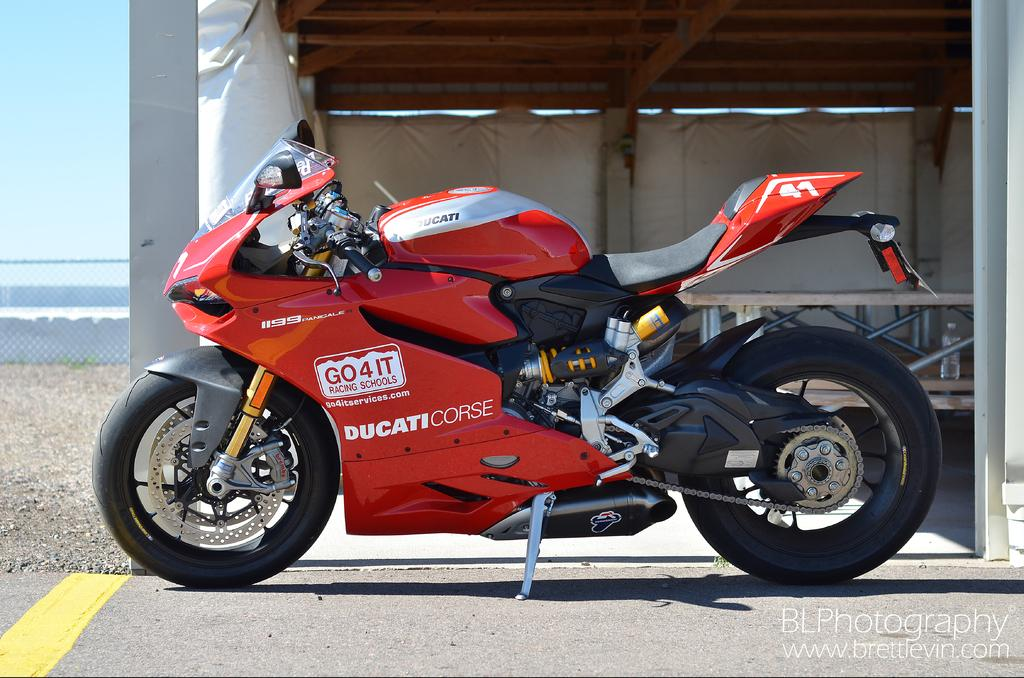<image>
Present a compact description of the photo's key features. A red Ducati Corse street bike is parked by a picnic table. 